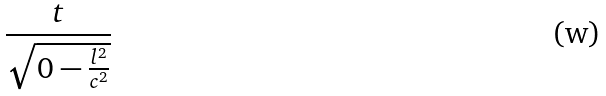<formula> <loc_0><loc_0><loc_500><loc_500>\frac { t } { \sqrt { 0 - \frac { l ^ { 2 } } { c ^ { 2 } } } }</formula> 